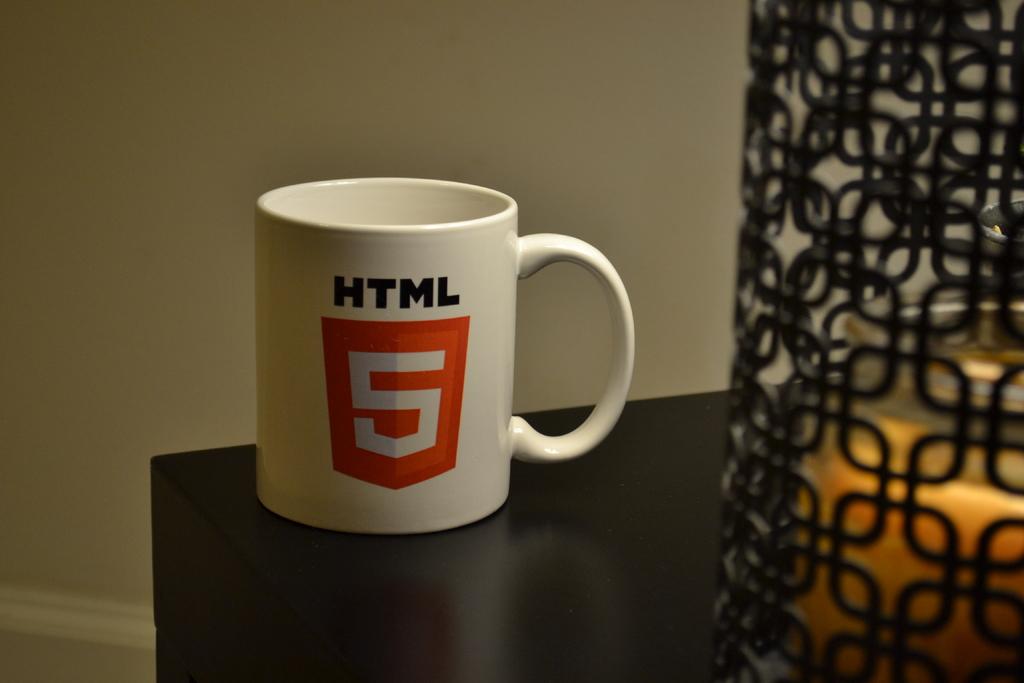Which version of html is the mug featuring?
Make the answer very short. 5. What is the first letter written in black?
Keep it short and to the point. H. 